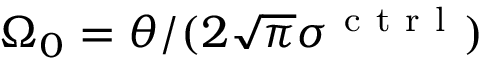<formula> <loc_0><loc_0><loc_500><loc_500>\Omega _ { 0 } = \theta / ( 2 \sqrt { \pi } \sigma ^ { c t r l } )</formula> 